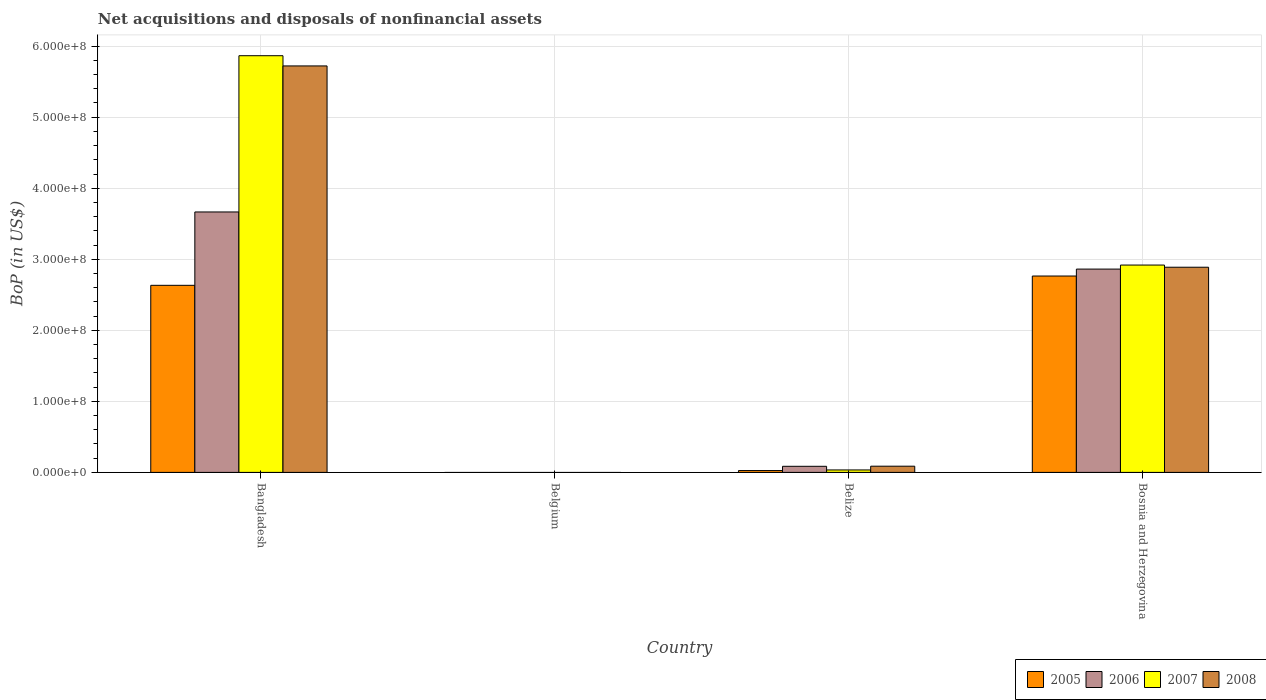How many different coloured bars are there?
Ensure brevity in your answer.  4. What is the Balance of Payments in 2007 in Bosnia and Herzegovina?
Provide a short and direct response. 2.92e+08. Across all countries, what is the maximum Balance of Payments in 2007?
Give a very brief answer. 5.87e+08. In which country was the Balance of Payments in 2007 maximum?
Ensure brevity in your answer.  Bangladesh. What is the total Balance of Payments in 2008 in the graph?
Your response must be concise. 8.70e+08. What is the difference between the Balance of Payments in 2008 in Bangladesh and that in Belize?
Make the answer very short. 5.63e+08. What is the difference between the Balance of Payments in 2005 in Belgium and the Balance of Payments in 2006 in Bangladesh?
Offer a very short reply. -3.67e+08. What is the average Balance of Payments in 2006 per country?
Ensure brevity in your answer.  1.65e+08. What is the difference between the Balance of Payments of/in 2008 and Balance of Payments of/in 2007 in Belize?
Provide a short and direct response. 5.28e+06. What is the ratio of the Balance of Payments in 2006 in Bangladesh to that in Belize?
Offer a very short reply. 42.8. What is the difference between the highest and the second highest Balance of Payments in 2006?
Offer a very short reply. -3.58e+08. What is the difference between the highest and the lowest Balance of Payments in 2007?
Give a very brief answer. 5.87e+08. In how many countries, is the Balance of Payments in 2007 greater than the average Balance of Payments in 2007 taken over all countries?
Give a very brief answer. 2. Is the sum of the Balance of Payments in 2008 in Bangladesh and Bosnia and Herzegovina greater than the maximum Balance of Payments in 2007 across all countries?
Your answer should be very brief. Yes. Are all the bars in the graph horizontal?
Make the answer very short. No. What is the difference between two consecutive major ticks on the Y-axis?
Make the answer very short. 1.00e+08. Are the values on the major ticks of Y-axis written in scientific E-notation?
Your response must be concise. Yes. What is the title of the graph?
Make the answer very short. Net acquisitions and disposals of nonfinancial assets. What is the label or title of the X-axis?
Offer a very short reply. Country. What is the label or title of the Y-axis?
Make the answer very short. BoP (in US$). What is the BoP (in US$) in 2005 in Bangladesh?
Your answer should be very brief. 2.63e+08. What is the BoP (in US$) in 2006 in Bangladesh?
Your answer should be very brief. 3.67e+08. What is the BoP (in US$) in 2007 in Bangladesh?
Make the answer very short. 5.87e+08. What is the BoP (in US$) of 2008 in Bangladesh?
Offer a terse response. 5.72e+08. What is the BoP (in US$) in 2005 in Belgium?
Your answer should be very brief. 0. What is the BoP (in US$) of 2006 in Belgium?
Keep it short and to the point. 0. What is the BoP (in US$) in 2007 in Belgium?
Provide a short and direct response. 0. What is the BoP (in US$) of 2008 in Belgium?
Ensure brevity in your answer.  0. What is the BoP (in US$) of 2005 in Belize?
Make the answer very short. 2.59e+06. What is the BoP (in US$) of 2006 in Belize?
Ensure brevity in your answer.  8.57e+06. What is the BoP (in US$) in 2007 in Belize?
Your answer should be very brief. 3.45e+06. What is the BoP (in US$) of 2008 in Belize?
Provide a succinct answer. 8.73e+06. What is the BoP (in US$) in 2005 in Bosnia and Herzegovina?
Keep it short and to the point. 2.76e+08. What is the BoP (in US$) in 2006 in Bosnia and Herzegovina?
Offer a very short reply. 2.86e+08. What is the BoP (in US$) of 2007 in Bosnia and Herzegovina?
Offer a terse response. 2.92e+08. What is the BoP (in US$) of 2008 in Bosnia and Herzegovina?
Give a very brief answer. 2.89e+08. Across all countries, what is the maximum BoP (in US$) in 2005?
Ensure brevity in your answer.  2.76e+08. Across all countries, what is the maximum BoP (in US$) in 2006?
Provide a succinct answer. 3.67e+08. Across all countries, what is the maximum BoP (in US$) in 2007?
Make the answer very short. 5.87e+08. Across all countries, what is the maximum BoP (in US$) of 2008?
Give a very brief answer. 5.72e+08. Across all countries, what is the minimum BoP (in US$) in 2007?
Give a very brief answer. 0. What is the total BoP (in US$) of 2005 in the graph?
Keep it short and to the point. 5.42e+08. What is the total BoP (in US$) in 2006 in the graph?
Your response must be concise. 6.61e+08. What is the total BoP (in US$) in 2007 in the graph?
Your response must be concise. 8.82e+08. What is the total BoP (in US$) in 2008 in the graph?
Provide a short and direct response. 8.70e+08. What is the difference between the BoP (in US$) of 2005 in Bangladesh and that in Belize?
Offer a terse response. 2.61e+08. What is the difference between the BoP (in US$) in 2006 in Bangladesh and that in Belize?
Your response must be concise. 3.58e+08. What is the difference between the BoP (in US$) in 2007 in Bangladesh and that in Belize?
Your answer should be compact. 5.83e+08. What is the difference between the BoP (in US$) in 2008 in Bangladesh and that in Belize?
Keep it short and to the point. 5.63e+08. What is the difference between the BoP (in US$) of 2005 in Bangladesh and that in Bosnia and Herzegovina?
Your answer should be compact. -1.31e+07. What is the difference between the BoP (in US$) in 2006 in Bangladesh and that in Bosnia and Herzegovina?
Give a very brief answer. 8.04e+07. What is the difference between the BoP (in US$) in 2007 in Bangladesh and that in Bosnia and Herzegovina?
Your answer should be compact. 2.95e+08. What is the difference between the BoP (in US$) in 2008 in Bangladesh and that in Bosnia and Herzegovina?
Offer a terse response. 2.83e+08. What is the difference between the BoP (in US$) in 2005 in Belize and that in Bosnia and Herzegovina?
Provide a succinct answer. -2.74e+08. What is the difference between the BoP (in US$) in 2006 in Belize and that in Bosnia and Herzegovina?
Your answer should be very brief. -2.78e+08. What is the difference between the BoP (in US$) of 2007 in Belize and that in Bosnia and Herzegovina?
Your answer should be compact. -2.88e+08. What is the difference between the BoP (in US$) in 2008 in Belize and that in Bosnia and Herzegovina?
Keep it short and to the point. -2.80e+08. What is the difference between the BoP (in US$) of 2005 in Bangladesh and the BoP (in US$) of 2006 in Belize?
Your answer should be compact. 2.55e+08. What is the difference between the BoP (in US$) of 2005 in Bangladesh and the BoP (in US$) of 2007 in Belize?
Your answer should be compact. 2.60e+08. What is the difference between the BoP (in US$) of 2005 in Bangladesh and the BoP (in US$) of 2008 in Belize?
Provide a succinct answer. 2.55e+08. What is the difference between the BoP (in US$) of 2006 in Bangladesh and the BoP (in US$) of 2007 in Belize?
Offer a terse response. 3.63e+08. What is the difference between the BoP (in US$) in 2006 in Bangladesh and the BoP (in US$) in 2008 in Belize?
Provide a short and direct response. 3.58e+08. What is the difference between the BoP (in US$) of 2007 in Bangladesh and the BoP (in US$) of 2008 in Belize?
Offer a terse response. 5.78e+08. What is the difference between the BoP (in US$) of 2005 in Bangladesh and the BoP (in US$) of 2006 in Bosnia and Herzegovina?
Ensure brevity in your answer.  -2.29e+07. What is the difference between the BoP (in US$) of 2005 in Bangladesh and the BoP (in US$) of 2007 in Bosnia and Herzegovina?
Your answer should be compact. -2.85e+07. What is the difference between the BoP (in US$) of 2005 in Bangladesh and the BoP (in US$) of 2008 in Bosnia and Herzegovina?
Offer a very short reply. -2.55e+07. What is the difference between the BoP (in US$) of 2006 in Bangladesh and the BoP (in US$) of 2007 in Bosnia and Herzegovina?
Provide a succinct answer. 7.47e+07. What is the difference between the BoP (in US$) in 2006 in Bangladesh and the BoP (in US$) in 2008 in Bosnia and Herzegovina?
Offer a terse response. 7.78e+07. What is the difference between the BoP (in US$) in 2007 in Bangladesh and the BoP (in US$) in 2008 in Bosnia and Herzegovina?
Offer a very short reply. 2.98e+08. What is the difference between the BoP (in US$) of 2005 in Belize and the BoP (in US$) of 2006 in Bosnia and Herzegovina?
Give a very brief answer. -2.84e+08. What is the difference between the BoP (in US$) in 2005 in Belize and the BoP (in US$) in 2007 in Bosnia and Herzegovina?
Provide a succinct answer. -2.89e+08. What is the difference between the BoP (in US$) in 2005 in Belize and the BoP (in US$) in 2008 in Bosnia and Herzegovina?
Offer a terse response. -2.86e+08. What is the difference between the BoP (in US$) of 2006 in Belize and the BoP (in US$) of 2007 in Bosnia and Herzegovina?
Give a very brief answer. -2.83e+08. What is the difference between the BoP (in US$) in 2006 in Belize and the BoP (in US$) in 2008 in Bosnia and Herzegovina?
Your response must be concise. -2.80e+08. What is the difference between the BoP (in US$) in 2007 in Belize and the BoP (in US$) in 2008 in Bosnia and Herzegovina?
Your response must be concise. -2.85e+08. What is the average BoP (in US$) in 2005 per country?
Your answer should be compact. 1.36e+08. What is the average BoP (in US$) of 2006 per country?
Offer a terse response. 1.65e+08. What is the average BoP (in US$) of 2007 per country?
Offer a terse response. 2.20e+08. What is the average BoP (in US$) in 2008 per country?
Make the answer very short. 2.17e+08. What is the difference between the BoP (in US$) in 2005 and BoP (in US$) in 2006 in Bangladesh?
Your response must be concise. -1.03e+08. What is the difference between the BoP (in US$) in 2005 and BoP (in US$) in 2007 in Bangladesh?
Offer a terse response. -3.23e+08. What is the difference between the BoP (in US$) in 2005 and BoP (in US$) in 2008 in Bangladesh?
Your answer should be compact. -3.09e+08. What is the difference between the BoP (in US$) of 2006 and BoP (in US$) of 2007 in Bangladesh?
Your answer should be compact. -2.20e+08. What is the difference between the BoP (in US$) in 2006 and BoP (in US$) in 2008 in Bangladesh?
Your answer should be very brief. -2.06e+08. What is the difference between the BoP (in US$) of 2007 and BoP (in US$) of 2008 in Bangladesh?
Make the answer very short. 1.44e+07. What is the difference between the BoP (in US$) of 2005 and BoP (in US$) of 2006 in Belize?
Provide a short and direct response. -5.98e+06. What is the difference between the BoP (in US$) of 2005 and BoP (in US$) of 2007 in Belize?
Keep it short and to the point. -8.56e+05. What is the difference between the BoP (in US$) of 2005 and BoP (in US$) of 2008 in Belize?
Provide a succinct answer. -6.14e+06. What is the difference between the BoP (in US$) of 2006 and BoP (in US$) of 2007 in Belize?
Make the answer very short. 5.12e+06. What is the difference between the BoP (in US$) of 2006 and BoP (in US$) of 2008 in Belize?
Give a very brief answer. -1.61e+05. What is the difference between the BoP (in US$) in 2007 and BoP (in US$) in 2008 in Belize?
Provide a succinct answer. -5.28e+06. What is the difference between the BoP (in US$) in 2005 and BoP (in US$) in 2006 in Bosnia and Herzegovina?
Your answer should be compact. -9.77e+06. What is the difference between the BoP (in US$) in 2005 and BoP (in US$) in 2007 in Bosnia and Herzegovina?
Offer a terse response. -1.54e+07. What is the difference between the BoP (in US$) in 2005 and BoP (in US$) in 2008 in Bosnia and Herzegovina?
Provide a succinct answer. -1.24e+07. What is the difference between the BoP (in US$) in 2006 and BoP (in US$) in 2007 in Bosnia and Herzegovina?
Keep it short and to the point. -5.67e+06. What is the difference between the BoP (in US$) in 2006 and BoP (in US$) in 2008 in Bosnia and Herzegovina?
Offer a terse response. -2.60e+06. What is the difference between the BoP (in US$) of 2007 and BoP (in US$) of 2008 in Bosnia and Herzegovina?
Offer a terse response. 3.07e+06. What is the ratio of the BoP (in US$) in 2005 in Bangladesh to that in Belize?
Provide a succinct answer. 101.69. What is the ratio of the BoP (in US$) of 2006 in Bangladesh to that in Belize?
Provide a short and direct response. 42.8. What is the ratio of the BoP (in US$) in 2007 in Bangladesh to that in Belize?
Your answer should be compact. 170.21. What is the ratio of the BoP (in US$) of 2008 in Bangladesh to that in Belize?
Give a very brief answer. 65.57. What is the ratio of the BoP (in US$) in 2005 in Bangladesh to that in Bosnia and Herzegovina?
Provide a succinct answer. 0.95. What is the ratio of the BoP (in US$) of 2006 in Bangladesh to that in Bosnia and Herzegovina?
Your answer should be compact. 1.28. What is the ratio of the BoP (in US$) of 2007 in Bangladesh to that in Bosnia and Herzegovina?
Offer a terse response. 2.01. What is the ratio of the BoP (in US$) of 2008 in Bangladesh to that in Bosnia and Herzegovina?
Your answer should be compact. 1.98. What is the ratio of the BoP (in US$) of 2005 in Belize to that in Bosnia and Herzegovina?
Your answer should be compact. 0.01. What is the ratio of the BoP (in US$) in 2006 in Belize to that in Bosnia and Herzegovina?
Your answer should be very brief. 0.03. What is the ratio of the BoP (in US$) of 2007 in Belize to that in Bosnia and Herzegovina?
Your response must be concise. 0.01. What is the ratio of the BoP (in US$) in 2008 in Belize to that in Bosnia and Herzegovina?
Offer a very short reply. 0.03. What is the difference between the highest and the second highest BoP (in US$) of 2005?
Offer a very short reply. 1.31e+07. What is the difference between the highest and the second highest BoP (in US$) of 2006?
Make the answer very short. 8.04e+07. What is the difference between the highest and the second highest BoP (in US$) in 2007?
Your answer should be very brief. 2.95e+08. What is the difference between the highest and the second highest BoP (in US$) in 2008?
Offer a terse response. 2.83e+08. What is the difference between the highest and the lowest BoP (in US$) of 2005?
Provide a succinct answer. 2.76e+08. What is the difference between the highest and the lowest BoP (in US$) in 2006?
Your answer should be very brief. 3.67e+08. What is the difference between the highest and the lowest BoP (in US$) of 2007?
Provide a short and direct response. 5.87e+08. What is the difference between the highest and the lowest BoP (in US$) of 2008?
Your answer should be compact. 5.72e+08. 